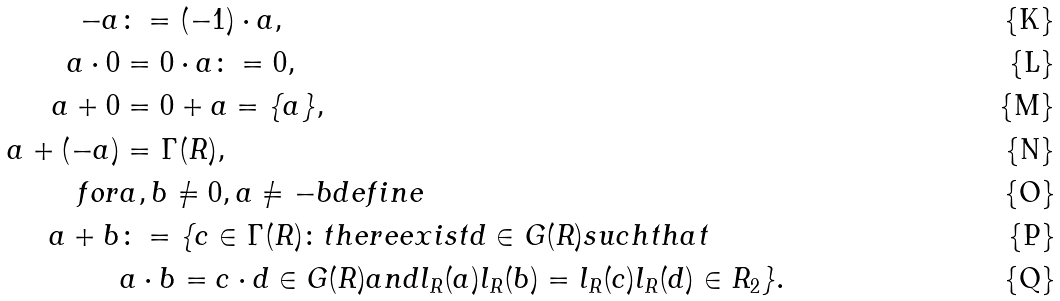<formula> <loc_0><loc_0><loc_500><loc_500>- a & \colon = ( - 1 ) \cdot a , \\ a \cdot 0 & = 0 \cdot a \colon = 0 , \\ a + 0 & = 0 + a = \{ a \} , \\ a + ( - a ) & = \Gamma ( R ) , \\ f o r & a , b \ne 0 , a \ne - b d e f i n e \\ a + b & \colon = \{ c \in \Gamma ( R ) \colon t h e r e e x i s t d \in G ( R ) s u c h t h a t \\ & a \cdot b = c \cdot d \in G ( R ) a n d l _ { R } ( a ) l _ { R } ( b ) = l _ { R } ( c ) l _ { R } ( d ) \in R _ { 2 } \} .</formula> 